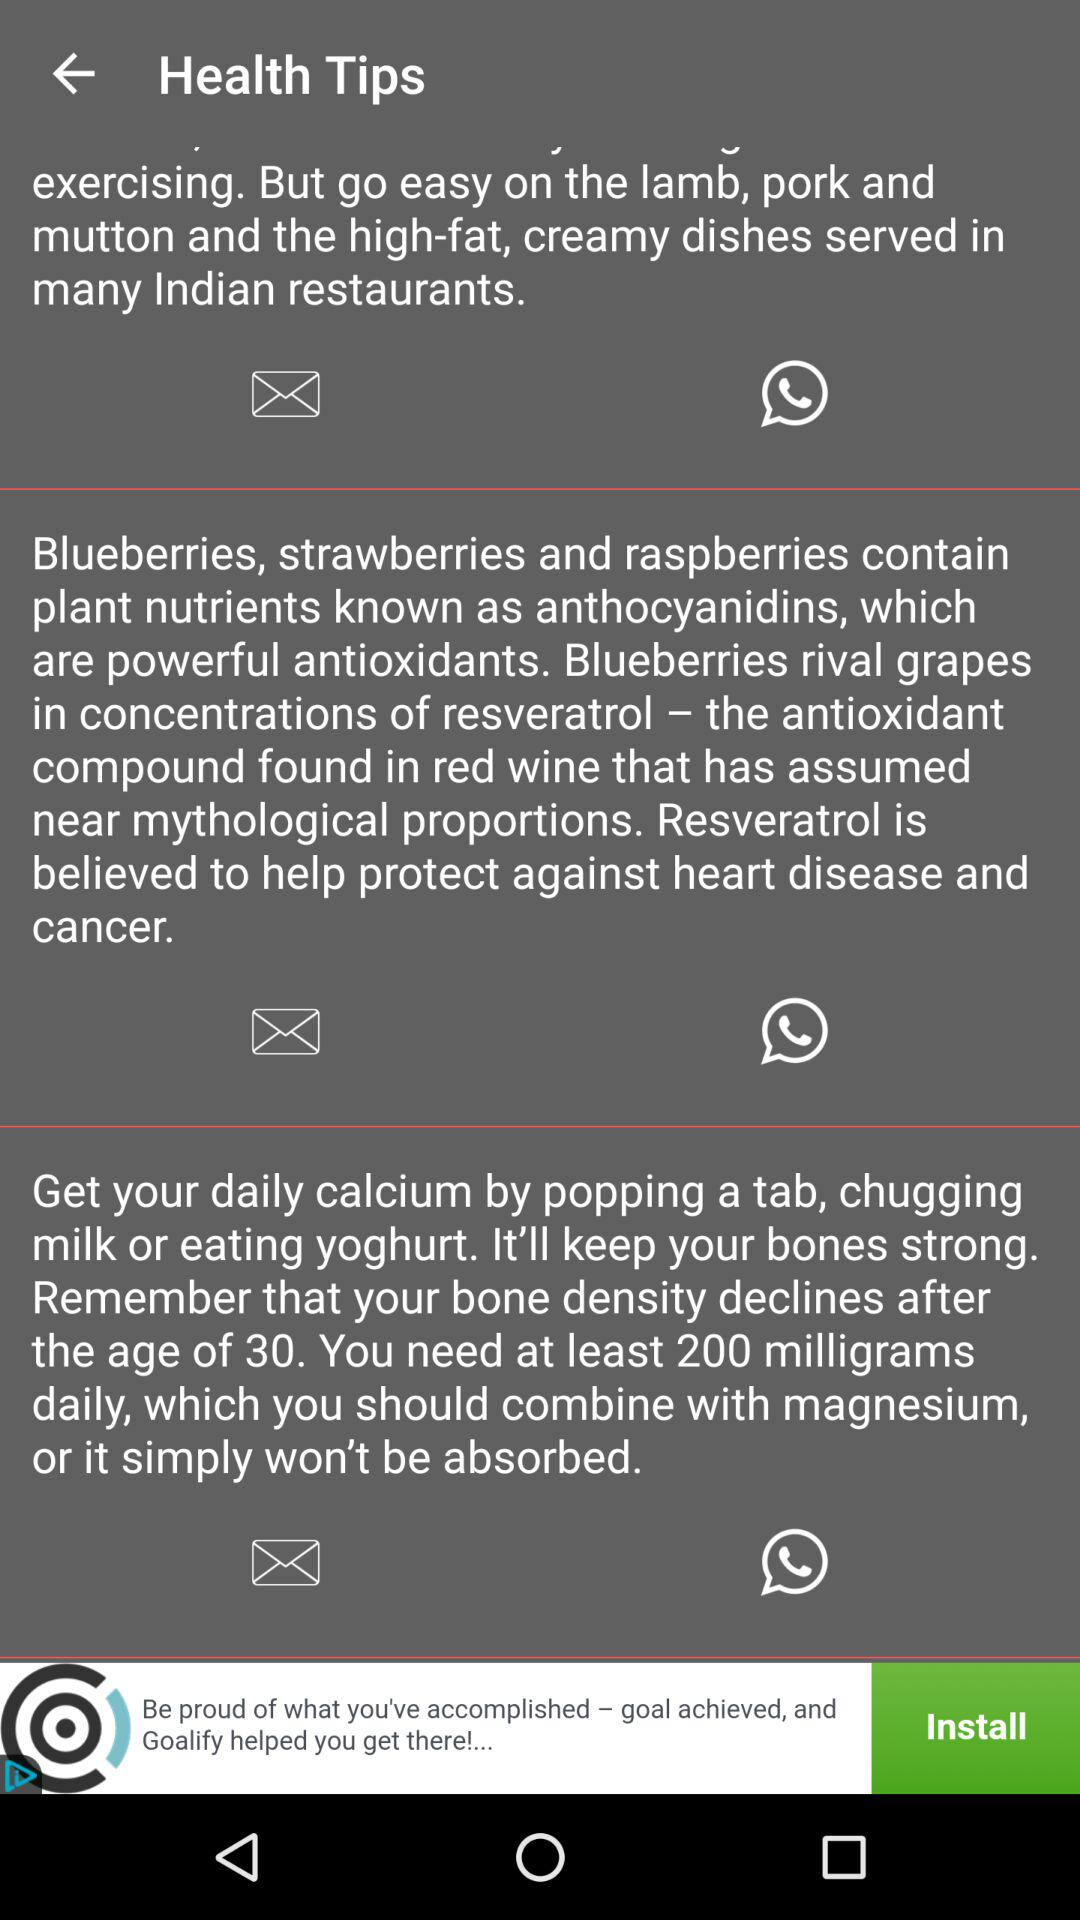After what age does the density of our bones decline? After the age of 30, the density of your bones declines. 